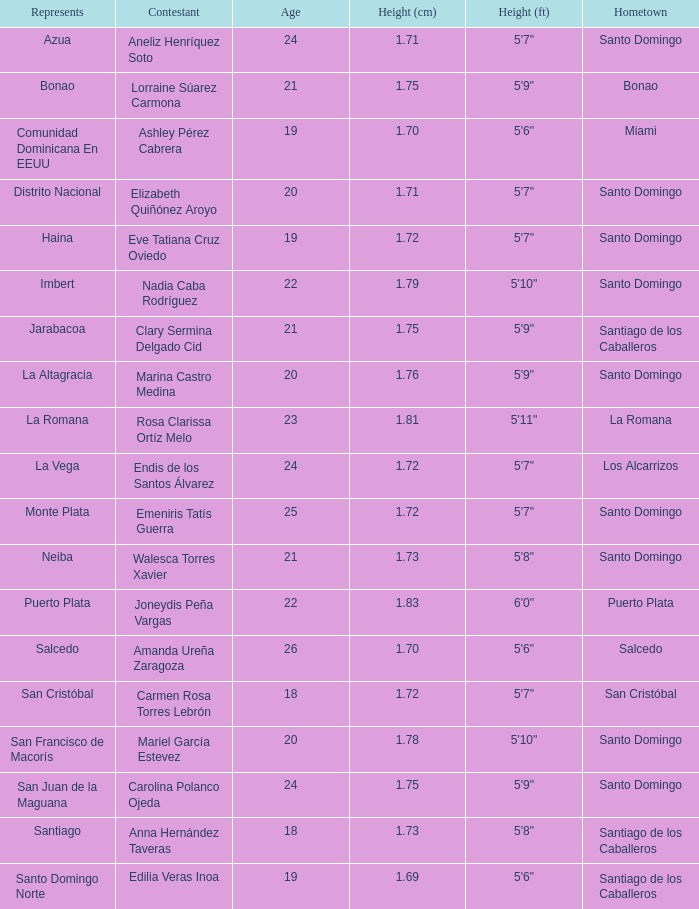Name the least age for distrito nacional 20.0. Can you parse all the data within this table? {'header': ['Represents', 'Contestant', 'Age', 'Height (cm)', 'Height (ft)', 'Hometown'], 'rows': [['Azua', 'Aneliz Henríquez Soto', '24', '1.71', '5\'7"', 'Santo Domingo'], ['Bonao', 'Lorraine Súarez Carmona', '21', '1.75', '5\'9"', 'Bonao'], ['Comunidad Dominicana En EEUU', 'Ashley Pérez Cabrera', '19', '1.70', '5\'6"', 'Miami'], ['Distrito Nacional', 'Elizabeth Quiñónez Aroyo', '20', '1.71', '5\'7"', 'Santo Domingo'], ['Haina', 'Eve Tatiana Cruz Oviedo', '19', '1.72', '5\'7"', 'Santo Domingo'], ['Imbert', 'Nadia Caba Rodríguez', '22', '1.79', '5\'10"', 'Santo Domingo'], ['Jarabacoa', 'Clary Sermina Delgado Cid', '21', '1.75', '5\'9"', 'Santiago de los Caballeros'], ['La Altagracia', 'Marina Castro Medina', '20', '1.76', '5\'9"', 'Santo Domingo'], ['La Romana', 'Rosa Clarissa Ortíz Melo', '23', '1.81', '5\'11"', 'La Romana'], ['La Vega', 'Endis de los Santos Álvarez', '24', '1.72', '5\'7"', 'Los Alcarrizos'], ['Monte Plata', 'Emeniris Tatís Guerra', '25', '1.72', '5\'7"', 'Santo Domingo'], ['Neiba', 'Walesca Torres Xavier', '21', '1.73', '5\'8"', 'Santo Domingo'], ['Puerto Plata', 'Joneydis Peña Vargas', '22', '1.83', '6\'0"', 'Puerto Plata'], ['Salcedo', 'Amanda Ureña Zaragoza', '26', '1.70', '5\'6"', 'Salcedo'], ['San Cristóbal', 'Carmen Rosa Torres Lebrón', '18', '1.72', '5\'7"', 'San Cristóbal'], ['San Francisco de Macorís', 'Mariel García Estevez', '20', '1.78', '5\'10"', 'Santo Domingo'], ['San Juan de la Maguana', 'Carolina Polanco Ojeda', '24', '1.75', '5\'9"', 'Santo Domingo'], ['Santiago', 'Anna Hernández Taveras', '18', '1.73', '5\'8"', 'Santiago de los Caballeros'], ['Santo Domingo Norte', 'Edilia Veras Inoa', '19', '1.69', '5\'6"', 'Santiago de los Caballeros']]} 